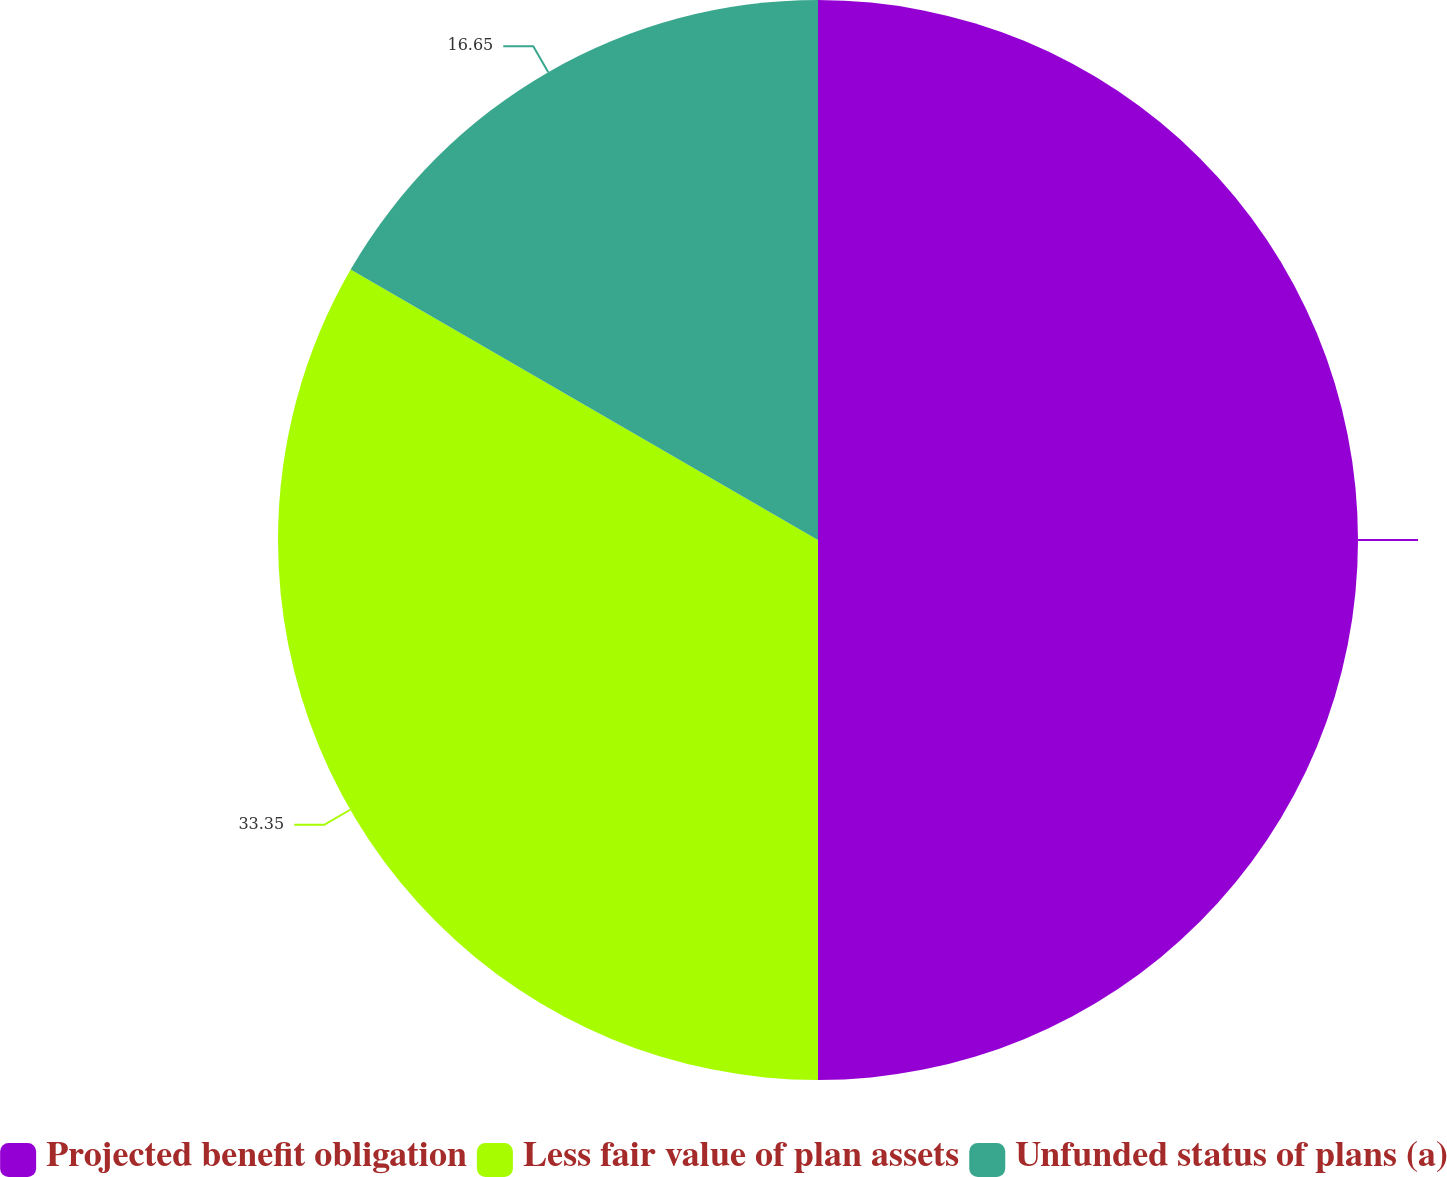Convert chart. <chart><loc_0><loc_0><loc_500><loc_500><pie_chart><fcel>Projected benefit obligation<fcel>Less fair value of plan assets<fcel>Unfunded status of plans (a)<nl><fcel>50.0%<fcel>33.35%<fcel>16.65%<nl></chart> 